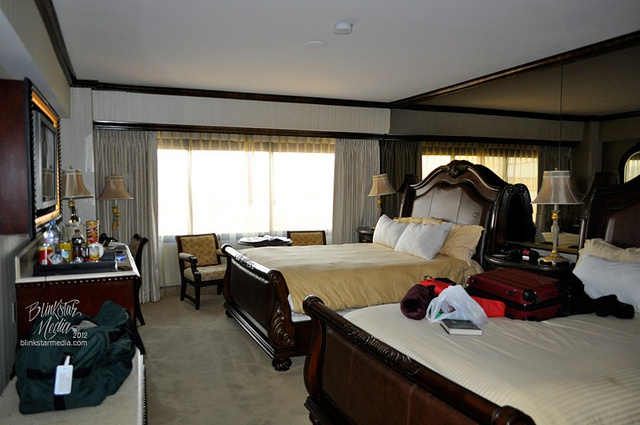Describe the objects in this image and their specific colors. I can see bed in gray, black, darkgray, tan, and olive tones, bed in gray and darkgray tones, suitcase in gray, black, maroon, and darkgray tones, chair in gray, black, olive, and maroon tones, and tv in gray, black, and darkgray tones in this image. 